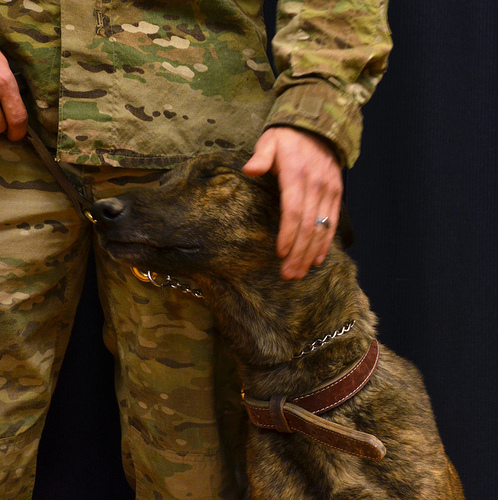<image>
Is the dog under the knee? No. The dog is not positioned under the knee. The vertical relationship between these objects is different. 